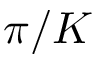<formula> <loc_0><loc_0><loc_500><loc_500>\pi / K</formula> 